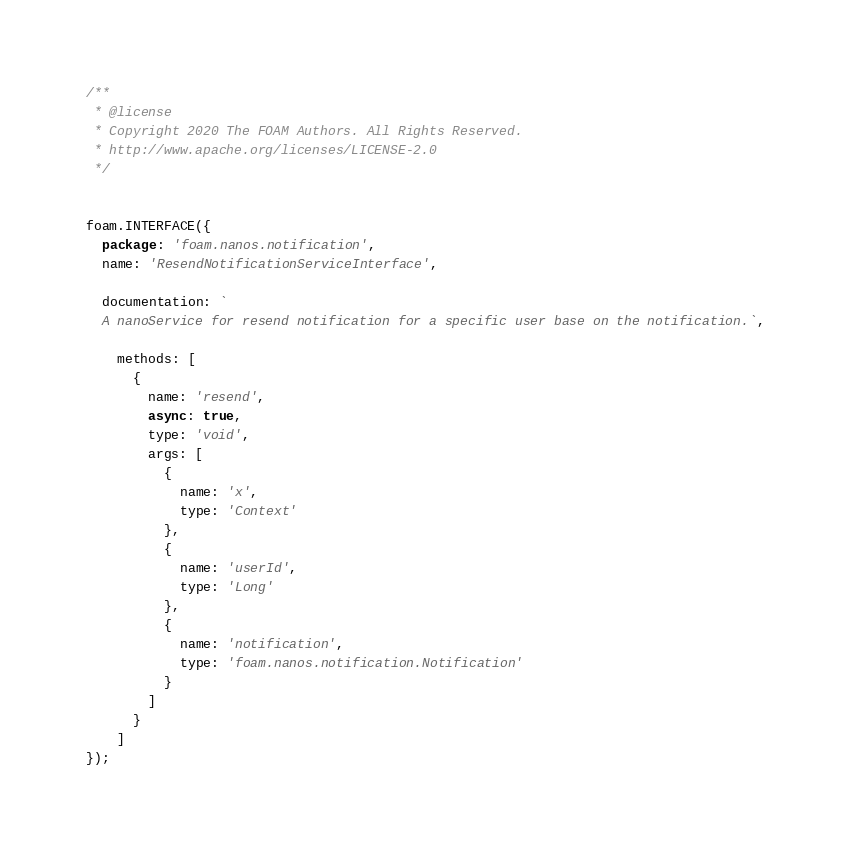Convert code to text. <code><loc_0><loc_0><loc_500><loc_500><_JavaScript_>/**
 * @license
 * Copyright 2020 The FOAM Authors. All Rights Reserved.
 * http://www.apache.org/licenses/LICENSE-2.0
 */


foam.INTERFACE({
  package: 'foam.nanos.notification',
  name: 'ResendNotificationServiceInterface',

  documentation: `
  A nanoService for resend notification for a specific user base on the notification.`,

    methods: [
      {
        name: 'resend',
        async: true,
        type: 'void',
        args: [
          {
            name: 'x',
            type: 'Context'
          },
          {
            name: 'userId',
            type: 'Long'
          },
          {
            name: 'notification',
            type: 'foam.nanos.notification.Notification'
          }
        ]
      }
    ]
});
</code> 